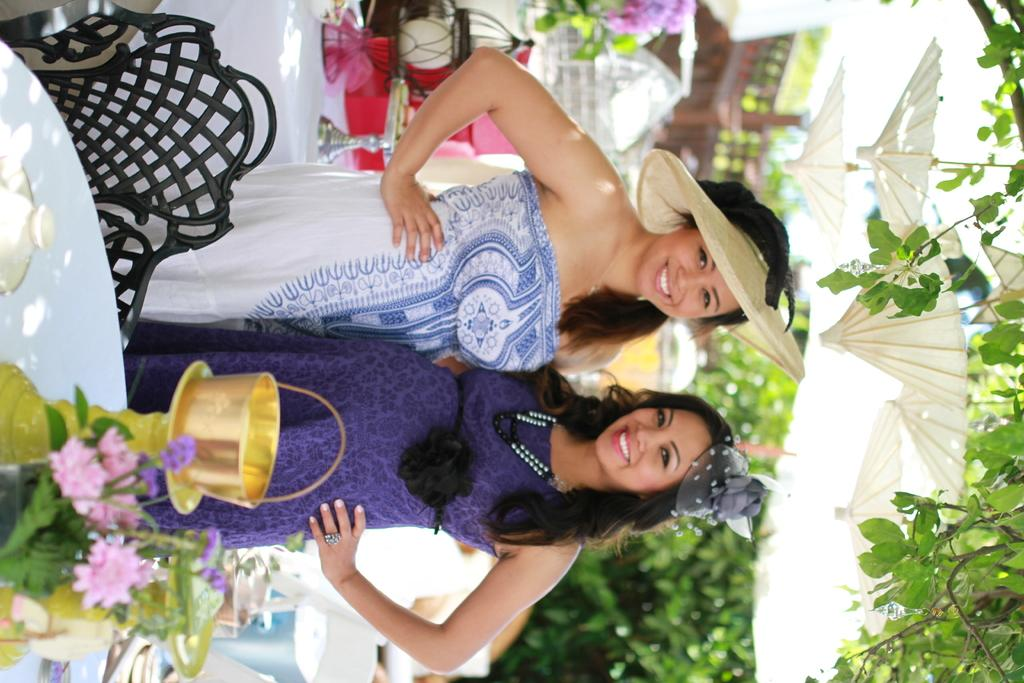How many women are in the image? There are two women in the image. What expression do the women have? The women are smiling. What type of furniture can be seen in the image? There are tables in the image. What is on one of the tables? There is a cloth on one of the tables. What decorative items are on the table with the cloth? There are flower vases on the table with the cloth. What type of seating is present in the image? There is a chair in the image. What can be seen in the background of the image? There are trees in the background of the image. What type of collar can be seen on the stranger in the image? There is no stranger present in the image, and therefore no collar can be observed. 